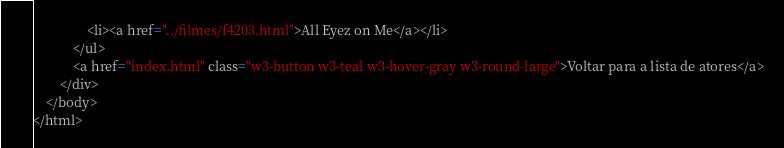<code> <loc_0><loc_0><loc_500><loc_500><_HTML_>				<li><a href="../filmes/f4203.html">All Eyez on Me</a></li>
			</ul>
            <a href="index.html" class="w3-button w3-teal w3-hover-gray w3-round-large">Voltar para a lista de atores</a>
        </div>
    </body>
</html></code> 